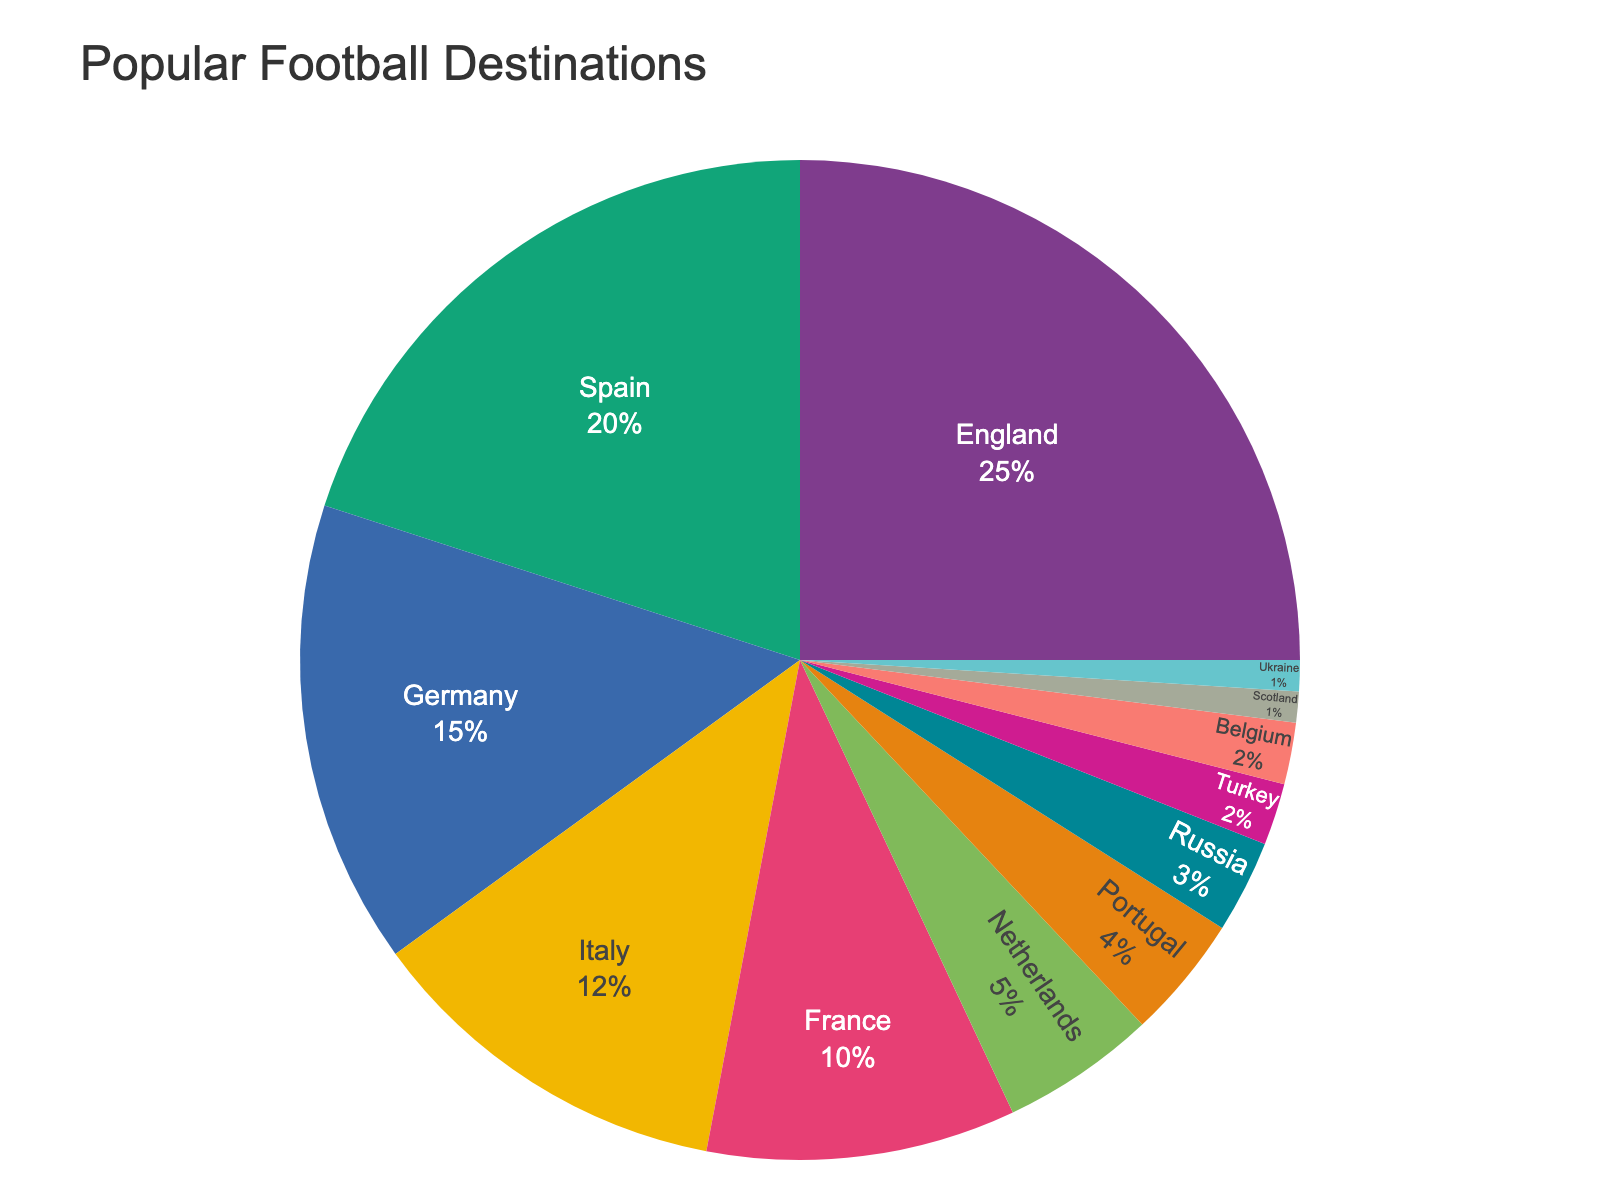What is the third most popular football destination by country? To find the third most popular football destination, look at the pie chart and identify the countries and their respective percentages. The third-largest segment will represent the third most popular destination.
Answer: Germany What is the combined percentage of the top three football destinations? Identify the percentages of the top three football destinations from the chart: England (25%), Spain (20%), and Germany (15%). Add these percentages together: 25 + 20 + 15 = 60.
Answer: 60% How much more popular is England compared to Portugal for football destinations? Find the percentage for England (25%) and Portugal (4%) from the chart. Subtract the percentage of Portugal from that of England: 25 - 4 = 21.
Answer: 21% Which country has a smaller percentage of popular football destinations, Turkey or Scotland? Look at the percentages for Turkey (2%) and Scotland (1%) on the pie chart. Scotland has a smaller percentage than Turkey.
Answer: Scotland What is the total percentage of all the countries that have 5% or less of the pie chart? Identify the countries with 5% or less: Netherlands (5%), Portugal (4%), Russia (3%), Turkey (2%), Belgium (2%), Scotland (1%), and Ukraine (1%). Add these percentages together: 5 + 4 + 3 + 2 + 2 + 1 + 1 = 18.
Answer: 18% Which countries are more popular for football destinations than France? Identify the percentage for France (10%) and then list the countries with a higher percentage: England (25%), Spain (20%), Germany (15%), and Italy (12%).
Answer: England, Spain, Germany, Italy What is the difference in popularity between the most popular and the least popular football destinations? Find the percentages for the most popular (England, 25%) and the least popular (Scotland and Ukraine, each 1%). Subtract the least popular from the most popular: 25 - 1 = 24.
Answer: 24 Are there more countries with a percentage less than 5% or more than 5% for football destinations? Count the countries with less than 5%: Portugal, Russia, Turkey, Belgium, Scotland, and Ukraine (6 countries). Count the countries with more than 5%: England, Spain, Germany, Italy, France, and Netherlands (6 countries). Comparing these counts shows they are equal.
Answer: Equal Which country is represented by the yellow segment in the pie chart? Identify the segment colored yellow on the pie chart and check its label.
Answer: (Assumed: Label from a typical color order, the specific answer might require viewing the chart directly.) What is the average percentage of the top four football destinations? Identify the percentages of the top four destinations: England (25%), Spain (20%), Germany (15%), and Italy (12%). Add these percentages and then divide by 4: (25 + 20 + 15 + 12) / 4 = 72 / 4 = 18.
Answer: 18% 